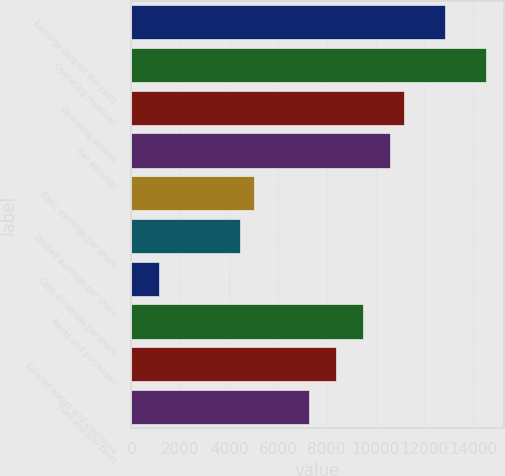Convert chart. <chart><loc_0><loc_0><loc_500><loc_500><bar_chart><fcel>Earnings data for the years<fcel>Operating revenues<fcel>Operating income<fcel>Net earnings<fcel>Basic earnings per share<fcel>Diluted earnings per share<fcel>Cash dividends per share<fcel>Rents and purchased<fcel>Salaries wages and employee<fcel>Fuel and fuel taxes<nl><fcel>12845.1<fcel>14520.5<fcel>11169.7<fcel>10611.2<fcel>5026.53<fcel>4468.06<fcel>1117.24<fcel>9494.29<fcel>8377.35<fcel>7260.41<nl></chart> 